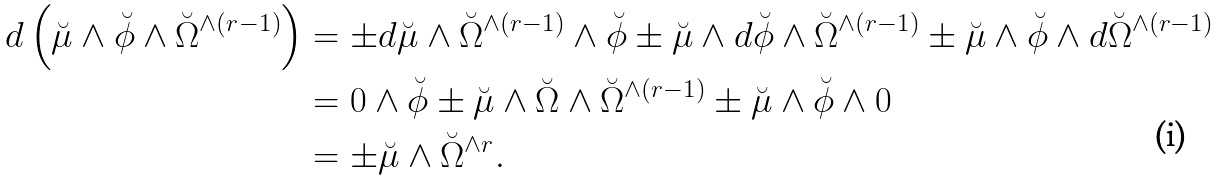<formula> <loc_0><loc_0><loc_500><loc_500>d \left ( \breve { \mu } \wedge \breve { \phi } \wedge \breve { \Omega } ^ { \wedge ( r - 1 ) } \right ) & = \pm d \breve { \mu } \wedge \breve { \Omega } ^ { \wedge ( r - 1 ) } \wedge \breve { \phi } \pm \breve { \mu } \wedge d \breve { \phi } \wedge \breve { \Omega } ^ { \wedge ( r - 1 ) } \pm \breve { \mu } \wedge \breve { \phi } \wedge d \breve { \Omega } ^ { \wedge ( r - 1 ) } \\ & = 0 \wedge \breve { \phi } \pm \breve { \mu } \wedge \breve { \Omega } \wedge \breve { \Omega } ^ { \wedge ( r - 1 ) } \pm \breve { \mu } \wedge \breve { \phi } \wedge 0 \\ & = \pm \breve { \mu } \wedge \breve { \Omega } ^ { \wedge r } .</formula> 